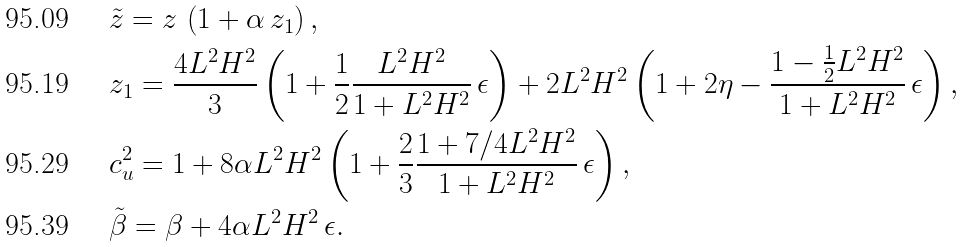Convert formula to latex. <formula><loc_0><loc_0><loc_500><loc_500>& \tilde { z } = z \, \left ( 1 + \alpha \, z _ { 1 } \right ) , \\ & z _ { 1 } = \frac { 4 L ^ { 2 } H ^ { 2 } } { 3 } \left ( 1 + \frac { 1 } { 2 } \frac { L ^ { 2 } H ^ { 2 } } { 1 + L ^ { 2 } H ^ { 2 } } \, \epsilon \right ) + 2 L ^ { 2 } H ^ { 2 } \left ( 1 + 2 \eta - \frac { 1 - \frac { 1 } { 2 } L ^ { 2 } H ^ { 2 } } { 1 + L ^ { 2 } H ^ { 2 } } \, \epsilon \right ) , \\ & c _ { u } ^ { 2 } = 1 + 8 \alpha L ^ { 2 } H ^ { 2 } \left ( 1 + \frac { 2 } { 3 } \frac { 1 + 7 / 4 L ^ { 2 } H ^ { 2 } } { 1 + L ^ { 2 } H ^ { 2 } } \, \epsilon \right ) , \\ & \tilde { \beta } = \beta + 4 \alpha L ^ { 2 } H ^ { 2 } \, \epsilon .</formula> 